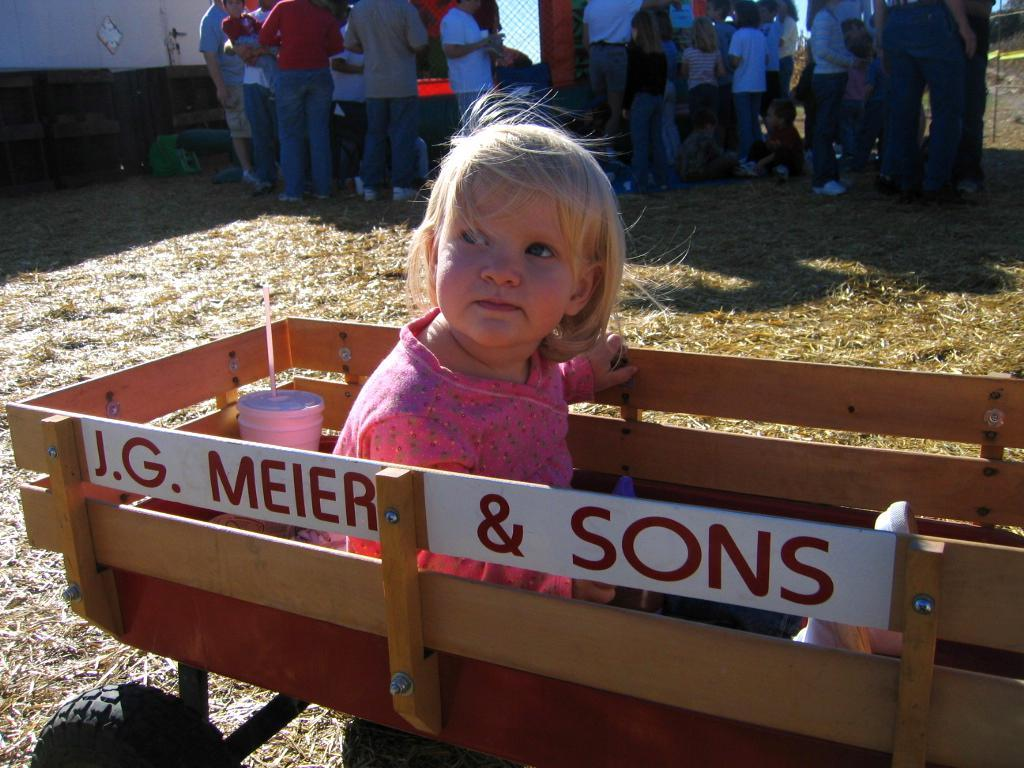What is the main subject of the image? The main subject of the image is a kid. What is the kid doing in the image? The kid is on a cart. What can be seen in the background of the image? There is a group of people and a wall in the background of the image. What type of stick is the kid holding in the image? There is no stick present in the image. Is the kid wearing a scarf in the image? The provided facts do not mention a scarf, so we cannot determine if the kid is wearing one. 